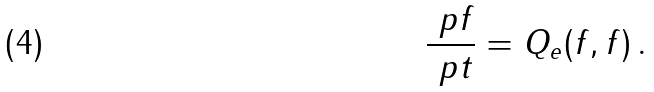<formula> <loc_0><loc_0><loc_500><loc_500>\frac { \ p f } { \ p t } = Q _ { e } ( f , f ) \, .</formula> 